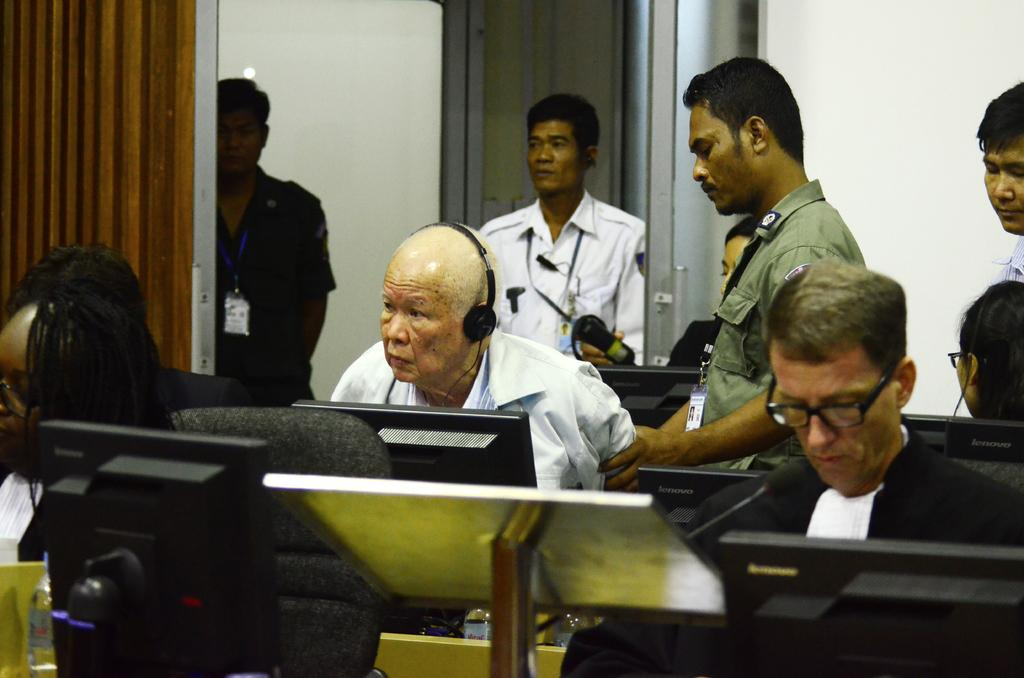How many people are in the image? There is a group of people in the image, but the exact number is not specified. What can be seen on some of the people's clothing? Some people are wearing ID cards in the image. What is one person using in the image? One person is wearing headphones in the image. What type of electronic devices can be seen in the image? There are monitors visible in the image. What is a feature of the background in the image? There is a wall in the image. What other objects can be seen in the image? There are other objects present in the image, but their specific nature is not mentioned. What type of cemetery can be seen in the image? There is no cemetery present in the image; it features a group of people, ID cards, headphones, monitors, a wall, and other unspecified objects. 